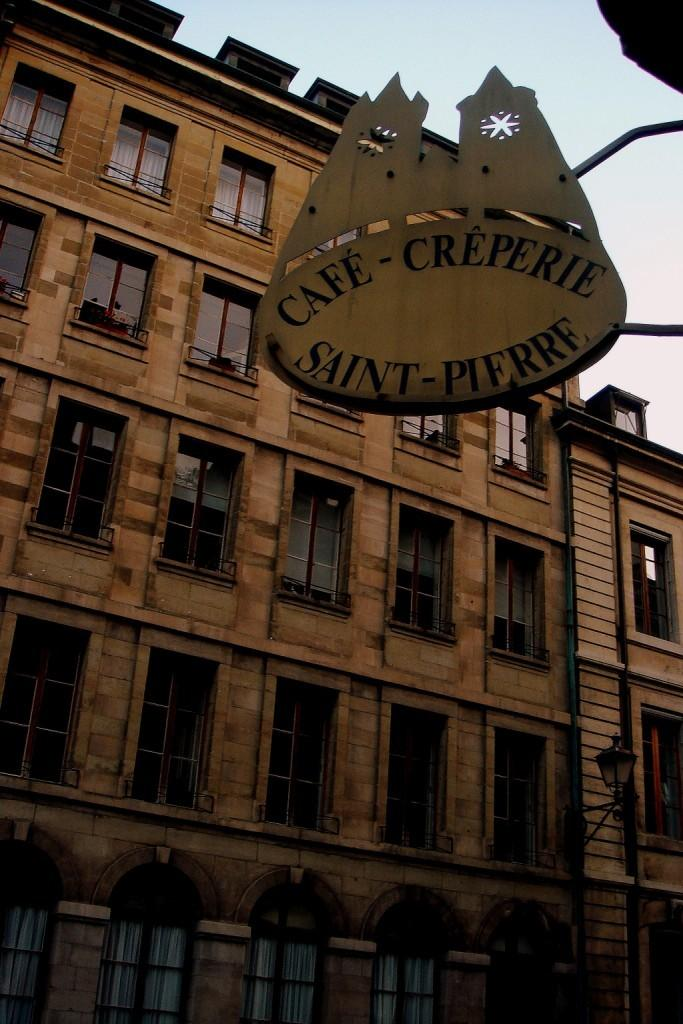What type of structure is present in the image? There is a building in the image. What feature of the building can be seen in the image? There are windows visible in the image. What can be seen in the background of the image? The sky is visible in the background of the image. How many trucks are parked in front of the building in the image? There is no information about trucks in the image; only the building and its windows are visible. 